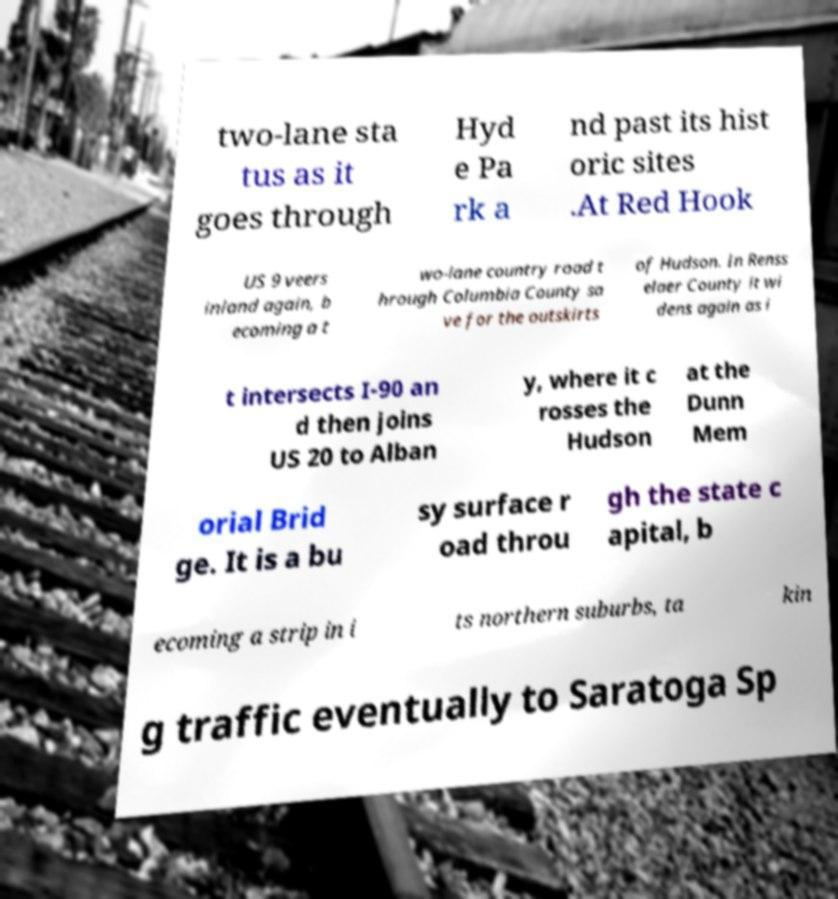For documentation purposes, I need the text within this image transcribed. Could you provide that? two-lane sta tus as it goes through Hyd e Pa rk a nd past its hist oric sites .At Red Hook US 9 veers inland again, b ecoming a t wo-lane country road t hrough Columbia County sa ve for the outskirts of Hudson. In Renss elaer County it wi dens again as i t intersects I-90 an d then joins US 20 to Alban y, where it c rosses the Hudson at the Dunn Mem orial Brid ge. It is a bu sy surface r oad throu gh the state c apital, b ecoming a strip in i ts northern suburbs, ta kin g traffic eventually to Saratoga Sp 